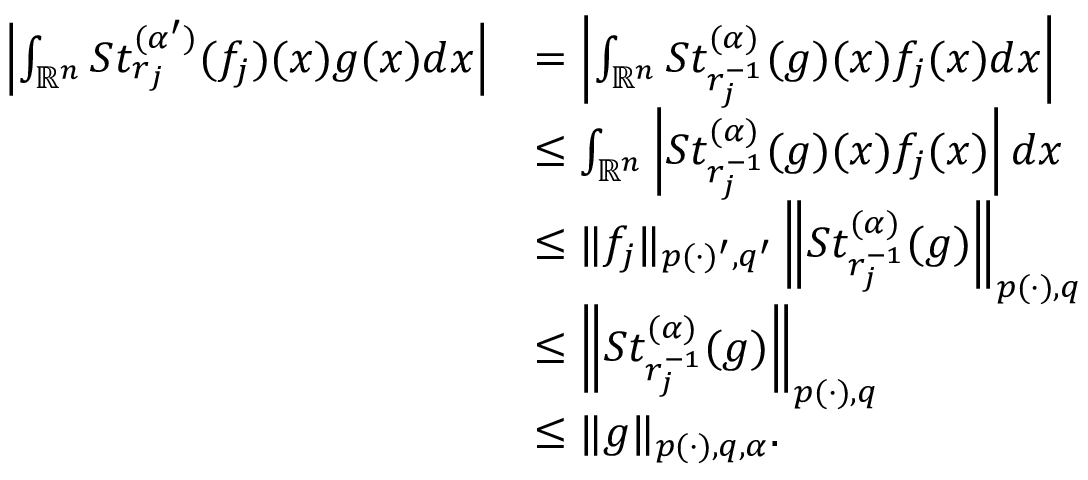Convert formula to latex. <formula><loc_0><loc_0><loc_500><loc_500>\begin{array} { r l } { \left | \int _ { { \mathbb { R } } ^ { n } } S t _ { r _ { j } } ^ { ( \alpha ^ { \prime } ) } ( f _ { j } ) ( x ) g ( x ) d x \right | } & { = \left | \int _ { { \mathbb { R } } ^ { n } } S t _ { r _ { j } ^ { - 1 } } ^ { ( \alpha ) } ( g ) ( x ) f _ { j } ( x ) d x \right | } \\ & { \leq \int _ { { \mathbb { R } } ^ { n } } \left | S t _ { r _ { j } ^ { - 1 } } ^ { ( \alpha ) } ( g ) ( x ) f _ { j } ( x ) \right | d x } \\ & { \leq \| f _ { j } \| _ { p ( \cdot ) ^ { \prime } , q ^ { \prime } } \left \| S t _ { r _ { j } ^ { - 1 } } ^ { ( \alpha ) } ( g ) \right \| _ { p ( \cdot ) , q } } \\ & { \leq \left \| S t _ { r _ { j } ^ { - 1 } } ^ { ( \alpha ) } ( g ) \right \| _ { p ( \cdot ) , q } } \\ & { \leq \| g \| _ { p ( \cdot ) , q , \alpha } . } \end{array}</formula> 